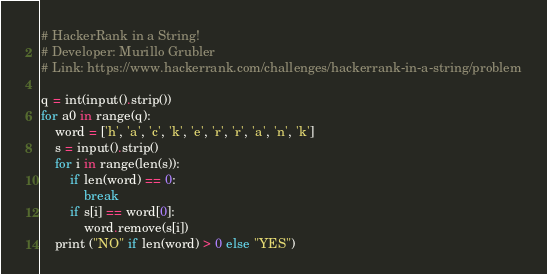<code> <loc_0><loc_0><loc_500><loc_500><_Python_># HackerRank in a String!
# Developer: Murillo Grubler
# Link: https://www.hackerrank.com/challenges/hackerrank-in-a-string/problem

q = int(input().strip())
for a0 in range(q):
    word = ['h', 'a', 'c', 'k', 'e', 'r', 'r', 'a', 'n', 'k']
    s = input().strip()
    for i in range(len(s)):
        if len(word) == 0:
            break
        if s[i] == word[0]:
            word.remove(s[i])
    print ("NO" if len(word) > 0 else "YES")</code> 